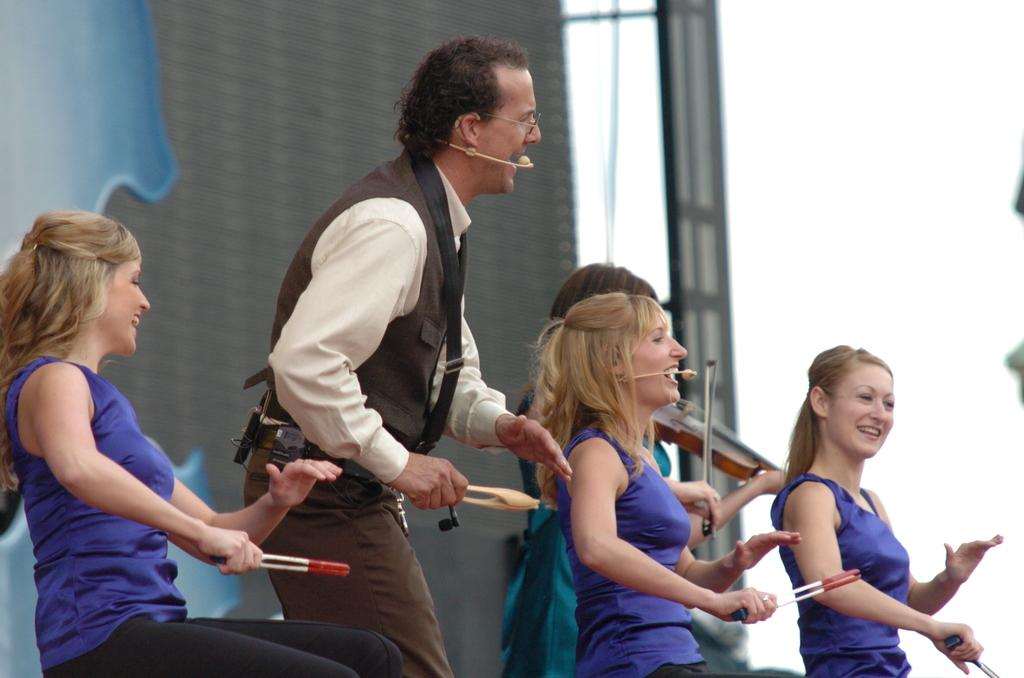What are the persons in the image doing? The persons in the image are performing on a dais. What can be seen in the background of the image? There is a screen and the sky visible in the background of the image. What type of print can be seen on the grain in the image? There is no grain or print present in the image. How many matches are visible on the dais in the image? There are no matches visible in the image; the persons are performing on the dais. 